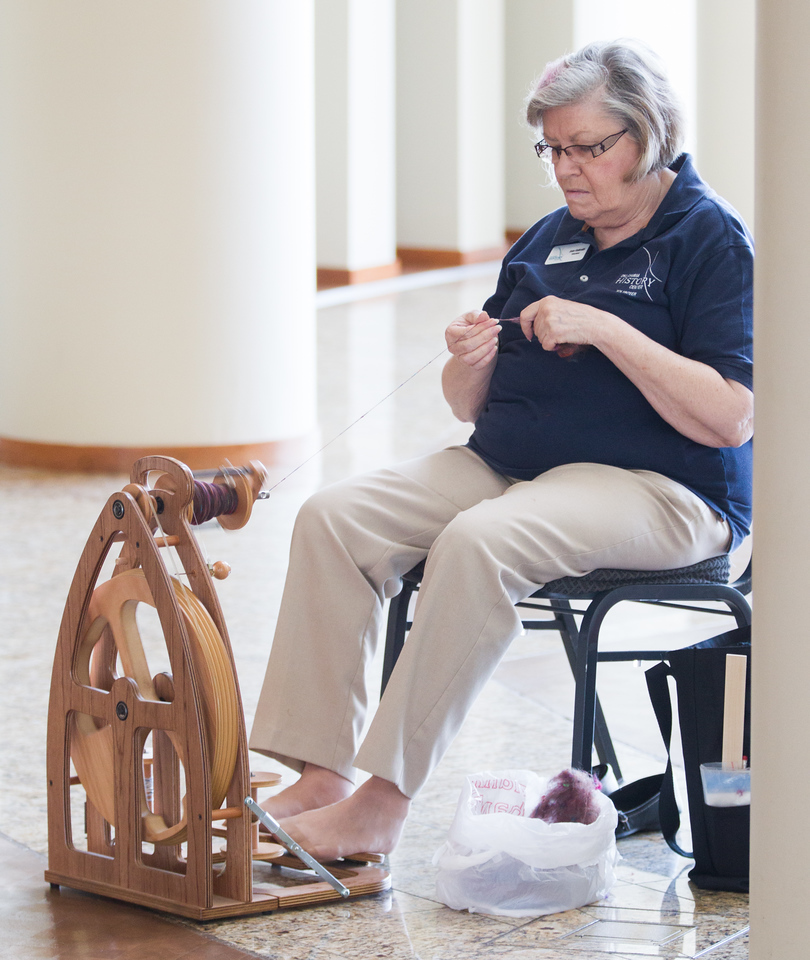What might be the level of the woman's expertise with spinning yarn based on the setup and her engagement with the equipment? Based on the organized setup and her confident engagement with the spinning wheel, it's likely that the woman has a high level of expertise in spinning yarn. The workspace is efficiently arranged, placing essential tools and raw materials within easy reach, which hints at a professional approach. Her focused expression and dexterous handling of the yarn indicate familiarity with the process. Furthermore, the evenness of the yarn on the bobbin and her composed posture suggest a well-practiced hand, further supporting the conclusion that she is experienced in this craft. 